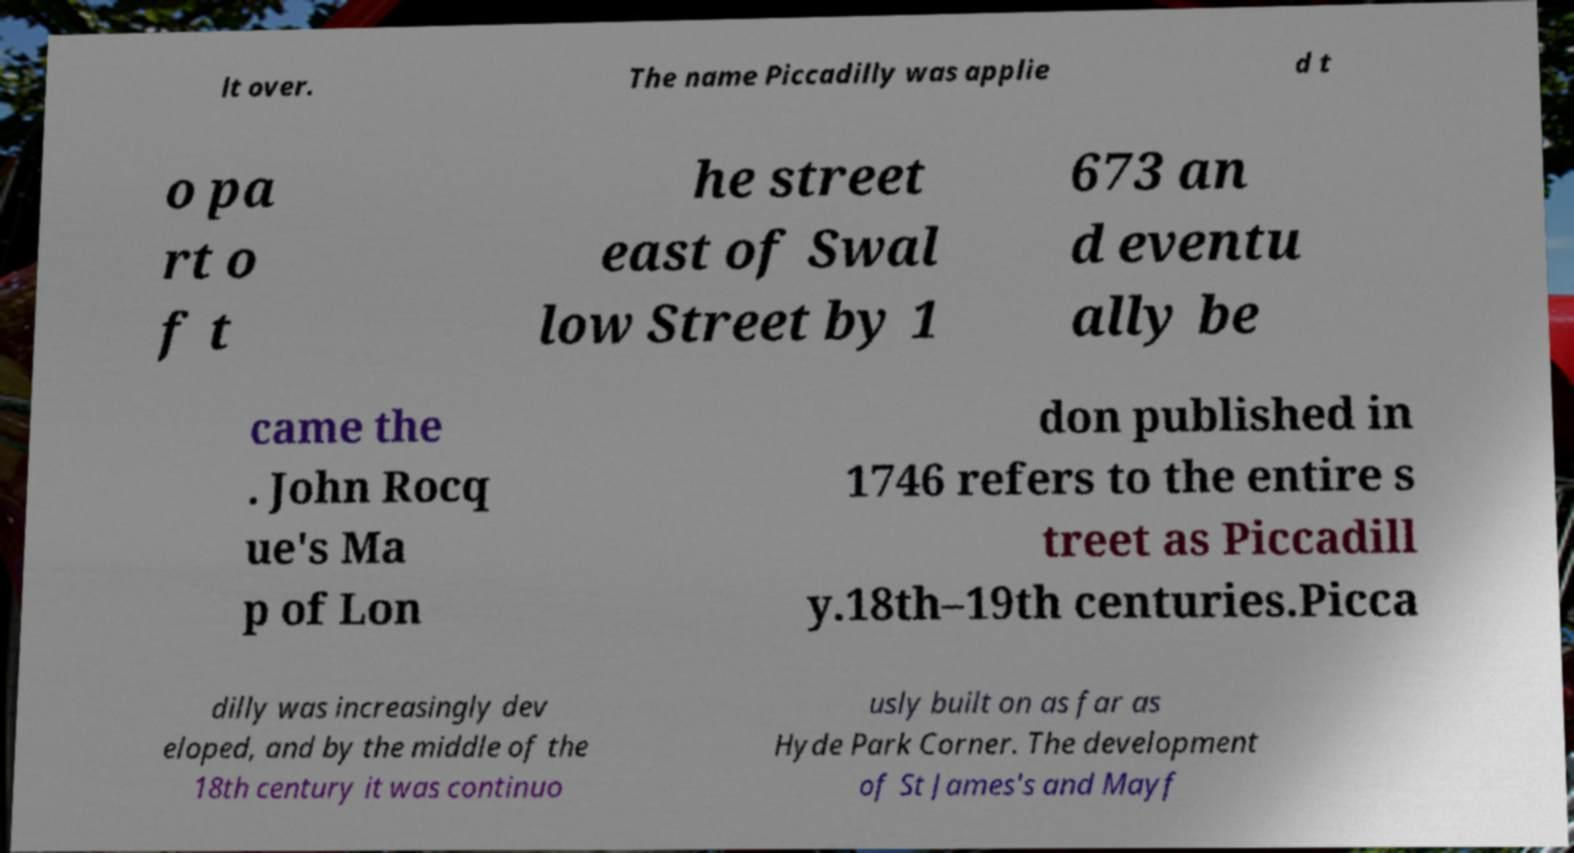Please read and relay the text visible in this image. What does it say? lt over. The name Piccadilly was applie d t o pa rt o f t he street east of Swal low Street by 1 673 an d eventu ally be came the . John Rocq ue's Ma p of Lon don published in 1746 refers to the entire s treet as Piccadill y.18th–19th centuries.Picca dilly was increasingly dev eloped, and by the middle of the 18th century it was continuo usly built on as far as Hyde Park Corner. The development of St James's and Mayf 